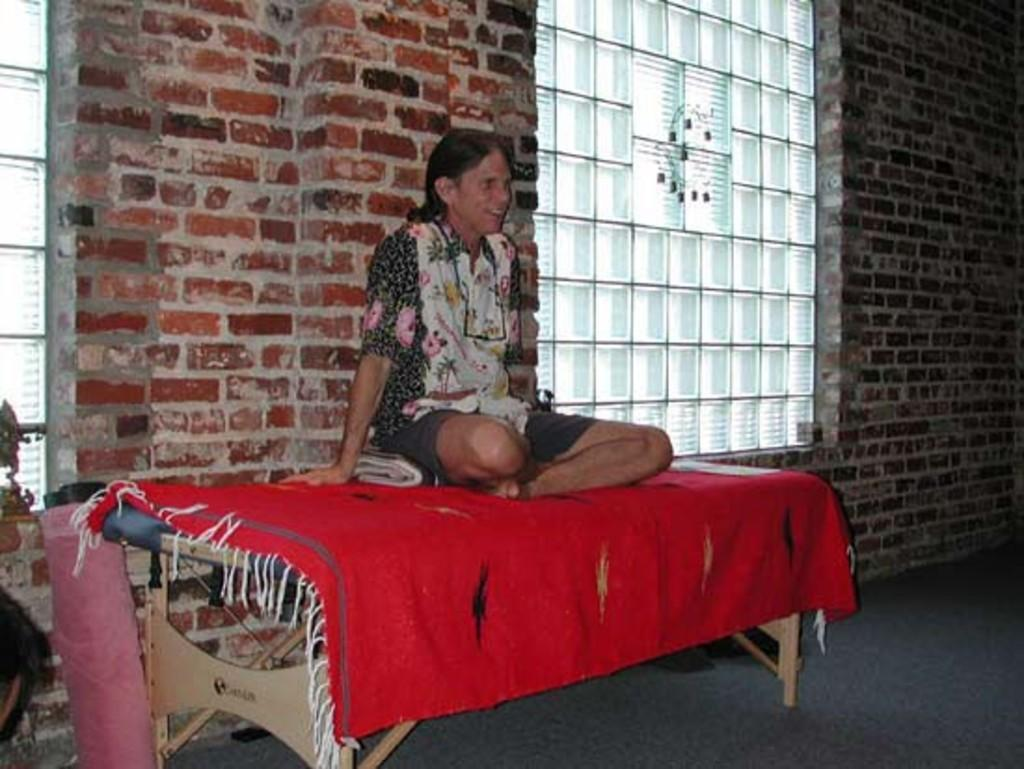What is the person in the image doing? The person is sitting on a table. What is covering the table? The table is covered with a red cloth. What type of material can be seen in the image? There is a brick wall and some glass visible in the image. What is on the ground in the image? There is an object on the ground. What type of side dish is being exchanged between the person and the wall in the image? There is no side dish or exchange happening between the person and the wall in the image. 